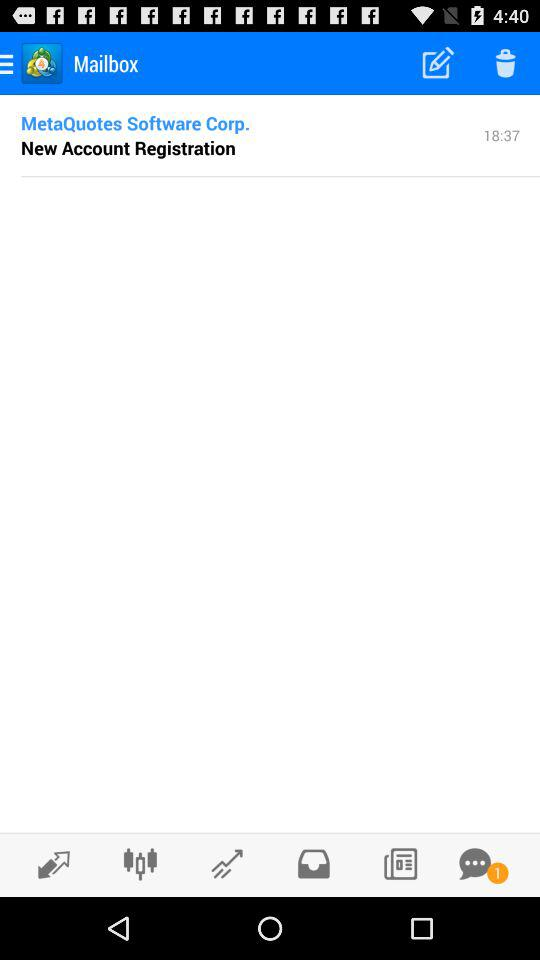How many emails are in the mailbox?
When the provided information is insufficient, respond with <no answer>. <no answer> 